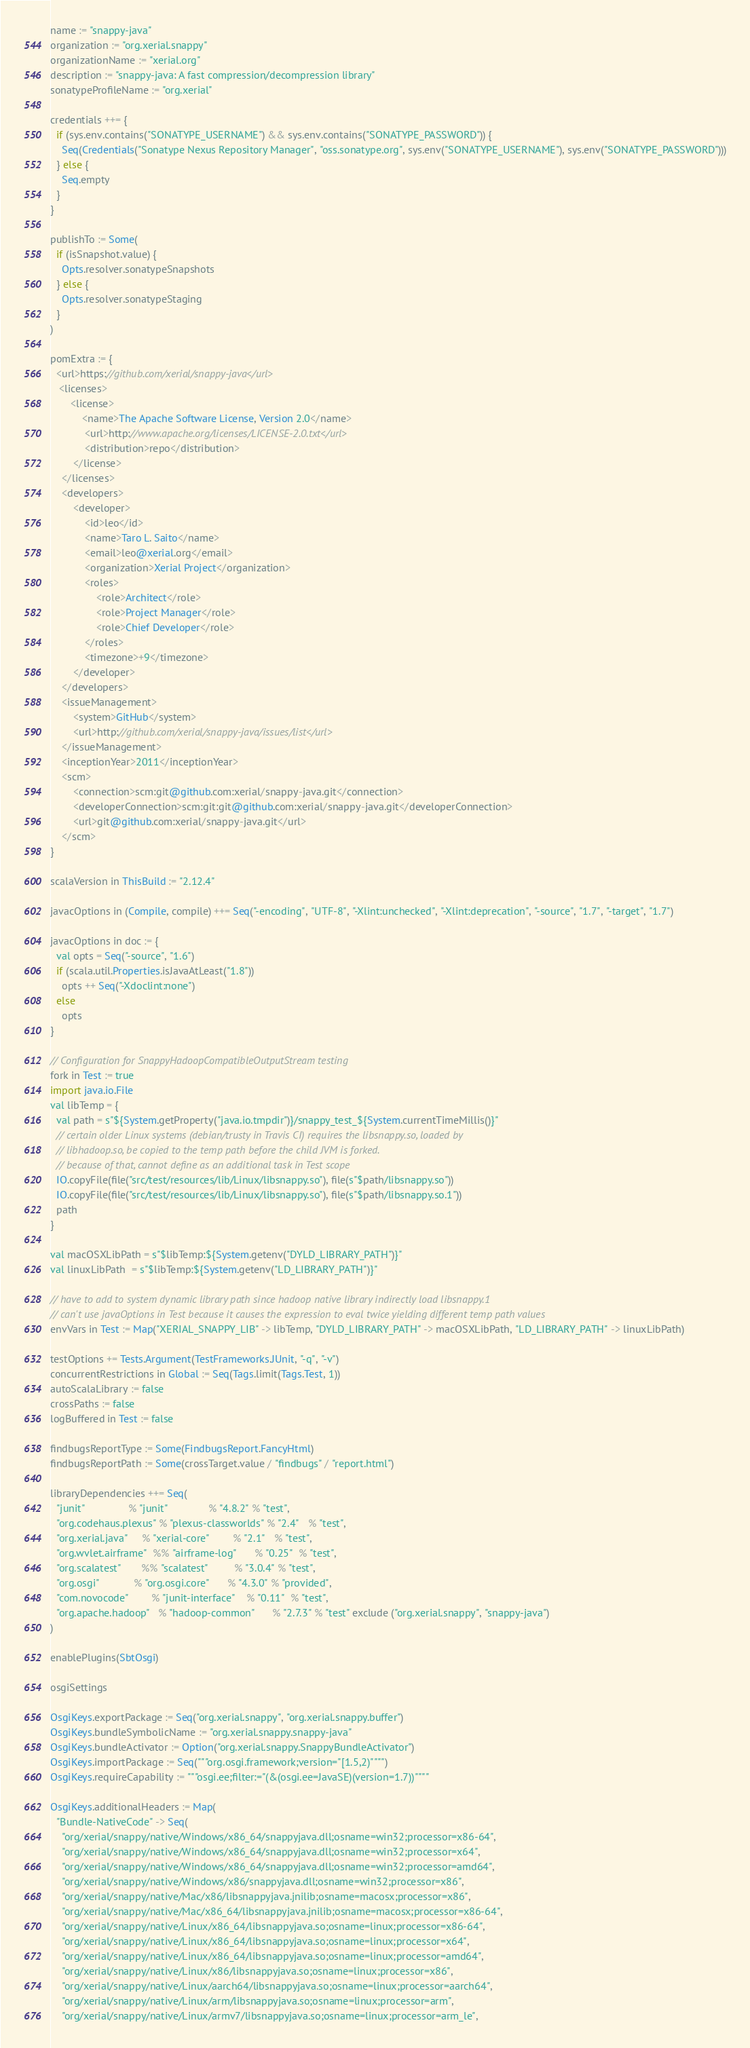<code> <loc_0><loc_0><loc_500><loc_500><_Scala_>name := "snappy-java"
organization := "org.xerial.snappy"
organizationName := "xerial.org"
description := "snappy-java: A fast compression/decompression library"
sonatypeProfileName := "org.xerial"

credentials ++= {
  if (sys.env.contains("SONATYPE_USERNAME") && sys.env.contains("SONATYPE_PASSWORD")) {
    Seq(Credentials("Sonatype Nexus Repository Manager", "oss.sonatype.org", sys.env("SONATYPE_USERNAME"), sys.env("SONATYPE_PASSWORD")))
  } else {
    Seq.empty
  }
}

publishTo := Some(
  if (isSnapshot.value) {
    Opts.resolver.sonatypeSnapshots
  } else {
    Opts.resolver.sonatypeStaging
  }
)

pomExtra := {
  <url>https://github.com/xerial/snappy-java</url>
   <licenses>
       <license>
           <name>The Apache Software License, Version 2.0</name>
            <url>http://www.apache.org/licenses/LICENSE-2.0.txt</url>
            <distribution>repo</distribution>
        </license>
    </licenses>
    <developers>
        <developer>
            <id>leo</id>
            <name>Taro L. Saito</name>
            <email>leo@xerial.org</email>
            <organization>Xerial Project</organization>
            <roles>
                <role>Architect</role>
                <role>Project Manager</role>
                <role>Chief Developer</role>
            </roles>
            <timezone>+9</timezone>
        </developer>
    </developers>
    <issueManagement>
        <system>GitHub</system>
        <url>http://github.com/xerial/snappy-java/issues/list</url>
    </issueManagement>
    <inceptionYear>2011</inceptionYear>
    <scm>
        <connection>scm:git@github.com:xerial/snappy-java.git</connection>
        <developerConnection>scm:git:git@github.com:xerial/snappy-java.git</developerConnection>
        <url>git@github.com:xerial/snappy-java.git</url>
    </scm>
}

scalaVersion in ThisBuild := "2.12.4"

javacOptions in (Compile, compile) ++= Seq("-encoding", "UTF-8", "-Xlint:unchecked", "-Xlint:deprecation", "-source", "1.7", "-target", "1.7")

javacOptions in doc := {
  val opts = Seq("-source", "1.6")
  if (scala.util.Properties.isJavaAtLeast("1.8"))
    opts ++ Seq("-Xdoclint:none")
  else
    opts
}

// Configuration for SnappyHadoopCompatibleOutputStream testing
fork in Test := true
import java.io.File
val libTemp = {
  val path = s"${System.getProperty("java.io.tmpdir")}/snappy_test_${System.currentTimeMillis()}"
  // certain older Linux systems (debian/trusty in Travis CI) requires the libsnappy.so, loaded by
  // libhadoop.so, be copied to the temp path before the child JVM is forked.
  // because of that, cannot define as an additional task in Test scope
  IO.copyFile(file("src/test/resources/lib/Linux/libsnappy.so"), file(s"$path/libsnappy.so"))
  IO.copyFile(file("src/test/resources/lib/Linux/libsnappy.so"), file(s"$path/libsnappy.so.1"))
  path
}

val macOSXLibPath = s"$libTemp:${System.getenv("DYLD_LIBRARY_PATH")}"
val linuxLibPath  = s"$libTemp:${System.getenv("LD_LIBRARY_PATH")}"

// have to add to system dynamic library path since hadoop native library indirectly load libsnappy.1
// can't use javaOptions in Test because it causes the expression to eval twice yielding different temp path values
envVars in Test := Map("XERIAL_SNAPPY_LIB" -> libTemp, "DYLD_LIBRARY_PATH" -> macOSXLibPath, "LD_LIBRARY_PATH" -> linuxLibPath)

testOptions += Tests.Argument(TestFrameworks.JUnit, "-q", "-v")
concurrentRestrictions in Global := Seq(Tags.limit(Tags.Test, 1))
autoScalaLibrary := false
crossPaths := false
logBuffered in Test := false

findbugsReportType := Some(FindbugsReport.FancyHtml)
findbugsReportPath := Some(crossTarget.value / "findbugs" / "report.html")

libraryDependencies ++= Seq(
  "junit"               % "junit"              % "4.8.2" % "test",
  "org.codehaus.plexus" % "plexus-classworlds" % "2.4"   % "test",
  "org.xerial.java"     % "xerial-core"        % "2.1"   % "test",
  "org.wvlet.airframe"  %% "airframe-log"      % "0.25"  % "test",
  "org.scalatest"       %% "scalatest"         % "3.0.4" % "test",
  "org.osgi"            % "org.osgi.core"      % "4.3.0" % "provided",
  "com.novocode"        % "junit-interface"    % "0.11"  % "test",
  "org.apache.hadoop"   % "hadoop-common"      % "2.7.3" % "test" exclude ("org.xerial.snappy", "snappy-java")
)

enablePlugins(SbtOsgi)

osgiSettings

OsgiKeys.exportPackage := Seq("org.xerial.snappy", "org.xerial.snappy.buffer")
OsgiKeys.bundleSymbolicName := "org.xerial.snappy.snappy-java"
OsgiKeys.bundleActivator := Option("org.xerial.snappy.SnappyBundleActivator")
OsgiKeys.importPackage := Seq("""org.osgi.framework;version="[1.5,2)"""")
OsgiKeys.requireCapability := """osgi.ee;filter:="(&(osgi.ee=JavaSE)(version=1.7))""""

OsgiKeys.additionalHeaders := Map(
  "Bundle-NativeCode" -> Seq(
    "org/xerial/snappy/native/Windows/x86_64/snappyjava.dll;osname=win32;processor=x86-64",
    "org/xerial/snappy/native/Windows/x86_64/snappyjava.dll;osname=win32;processor=x64",
    "org/xerial/snappy/native/Windows/x86_64/snappyjava.dll;osname=win32;processor=amd64",
    "org/xerial/snappy/native/Windows/x86/snappyjava.dll;osname=win32;processor=x86",
    "org/xerial/snappy/native/Mac/x86/libsnappyjava.jnilib;osname=macosx;processor=x86",
    "org/xerial/snappy/native/Mac/x86_64/libsnappyjava.jnilib;osname=macosx;processor=x86-64",
    "org/xerial/snappy/native/Linux/x86_64/libsnappyjava.so;osname=linux;processor=x86-64",
    "org/xerial/snappy/native/Linux/x86_64/libsnappyjava.so;osname=linux;processor=x64",
    "org/xerial/snappy/native/Linux/x86_64/libsnappyjava.so;osname=linux;processor=amd64",
    "org/xerial/snappy/native/Linux/x86/libsnappyjava.so;osname=linux;processor=x86",
    "org/xerial/snappy/native/Linux/aarch64/libsnappyjava.so;osname=linux;processor=aarch64",
    "org/xerial/snappy/native/Linux/arm/libsnappyjava.so;osname=linux;processor=arm",
    "org/xerial/snappy/native/Linux/armv7/libsnappyjava.so;osname=linux;processor=arm_le",</code> 